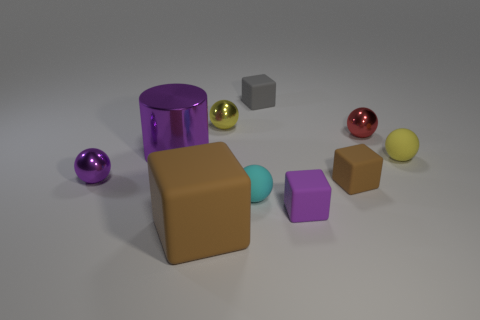The tiny block that is in front of the tiny purple shiny object and left of the small brown rubber object is made of what material?
Your answer should be compact. Rubber. Does the yellow sphere that is to the left of the gray matte block have the same size as the large purple metallic cylinder?
Give a very brief answer. No. What shape is the gray object?
Your answer should be very brief. Cube. There is a cyan sphere that is the same size as the gray matte thing; what material is it?
Your answer should be compact. Rubber. How many objects are either small gray rubber things or small cubes that are behind the small red metallic object?
Make the answer very short. 1. There is a cylinder that is the same material as the small red ball; what is its size?
Your response must be concise. Large. What is the shape of the tiny purple object that is left of the tiny matte object that is in front of the small cyan sphere?
Make the answer very short. Sphere. There is a matte cube that is in front of the cyan matte ball and behind the large rubber block; how big is it?
Ensure brevity in your answer.  Small. Is there a brown rubber thing of the same shape as the small gray rubber object?
Provide a short and direct response. Yes. Is there anything else that is the same shape as the gray object?
Offer a terse response. Yes. 